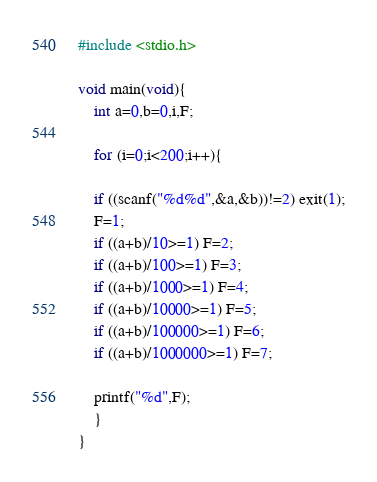Convert code to text. <code><loc_0><loc_0><loc_500><loc_500><_C_>#include <stdio.h>

void main(void){
	int a=0,b=0,i,F;
	
	for (i=0;i<200;i++){
	
	if ((scanf("%d%d",&a,&b))!=2) exit(1);
	F=1;
	if ((a+b)/10>=1) F=2;
	if ((a+b)/100>=1) F=3;
	if ((a+b)/1000>=1) F=4;
	if ((a+b)/10000>=1) F=5;
	if ((a+b)/100000>=1) F=6;
	if ((a+b)/1000000>=1) F=7;
	
	printf("%d",F);
	}
}</code> 